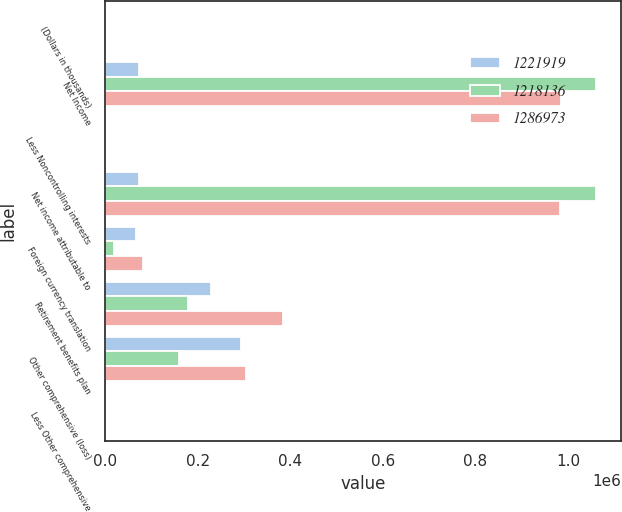<chart> <loc_0><loc_0><loc_500><loc_500><stacked_bar_chart><ecel><fcel>(Dollars in thousands)<fcel>Net Income<fcel>Less Noncontrolling interests<fcel>Net income attributable to<fcel>Foreign currency translation<fcel>Retirement benefits plan<fcel>Other comprehensive (loss)<fcel>Less Other comprehensive<nl><fcel>1.22192e+06<fcel>2019<fcel>73628.5<fcel>567<fcel>73628.5<fcel>66392<fcel>227783<fcel>294175<fcel>53<nl><fcel>1.21814e+06<fcel>2018<fcel>1.06132e+06<fcel>514<fcel>1.0608e+06<fcel>18575<fcel>179253<fcel>160678<fcel>440<nl><fcel>1.28697e+06<fcel>2017<fcel>983844<fcel>432<fcel>983412<fcel>80865<fcel>384784<fcel>303919<fcel>358<nl></chart> 